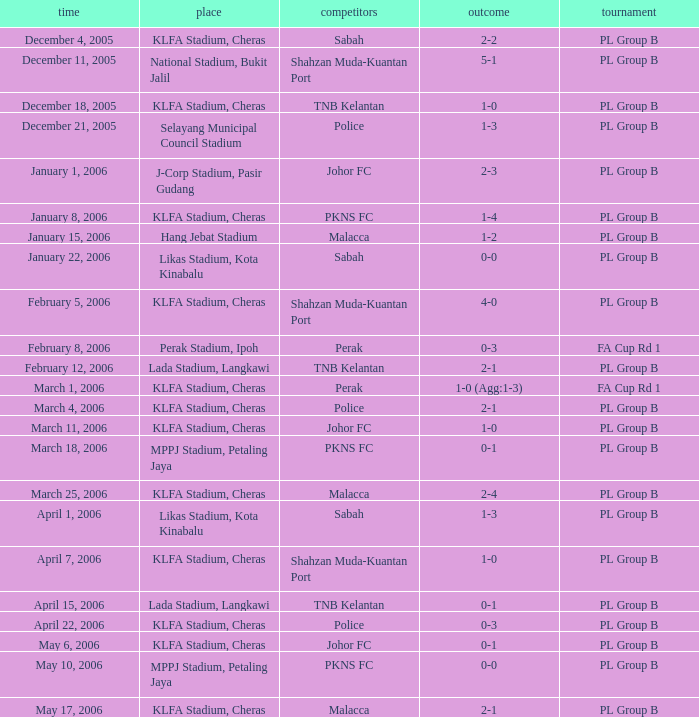Which Competition has Opponents of pkns fc, and a Score of 0-0? PL Group B. 